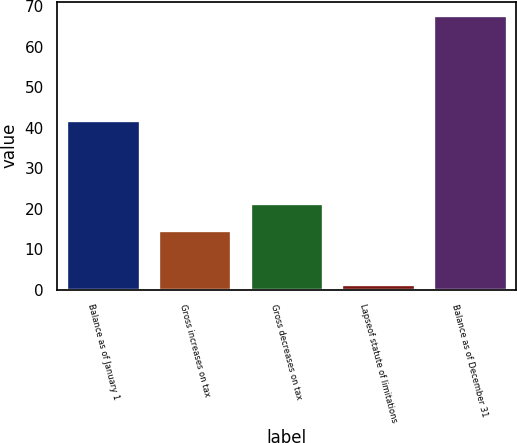Convert chart. <chart><loc_0><loc_0><loc_500><loc_500><bar_chart><fcel>Balance as of January 1<fcel>Gross increases on tax<fcel>Gross decreases on tax<fcel>Lapseof statute of limitations<fcel>Balance as of December 31<nl><fcel>41.9<fcel>14.76<fcel>21.39<fcel>1.5<fcel>67.8<nl></chart> 